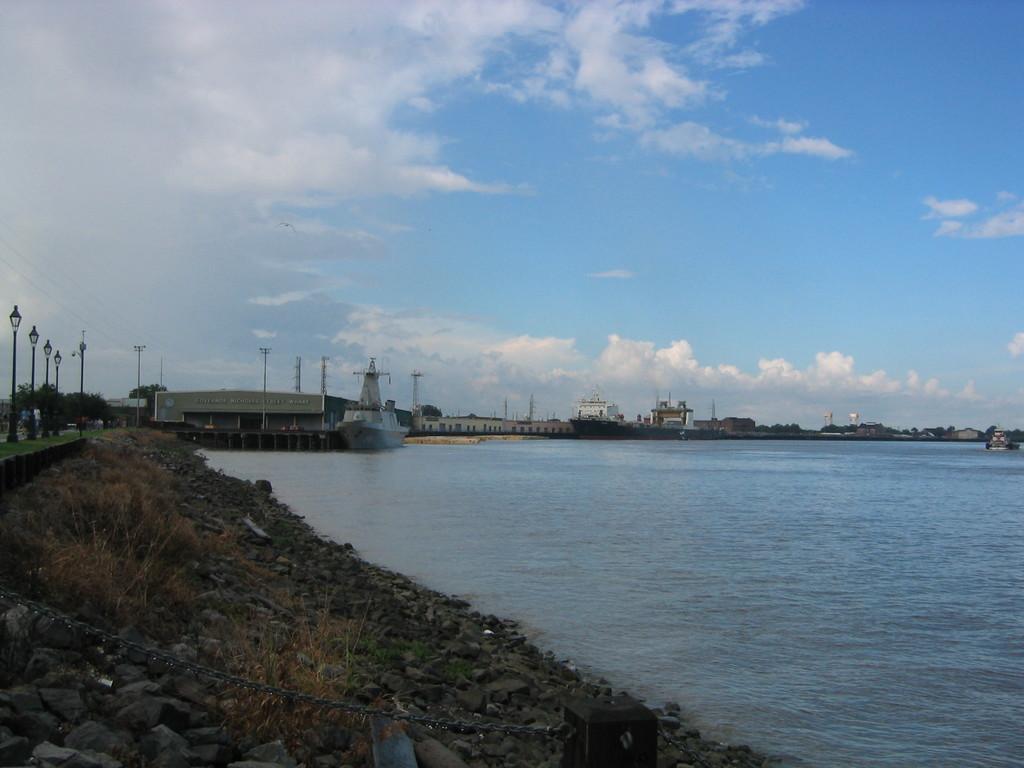Please provide a concise description of this image. To the right side of the image there is water. In the background of the image there are buildings,towers,sky,clouds. To the left side of the image there are light poles. At the bottom of the image there stones on dry grass. 